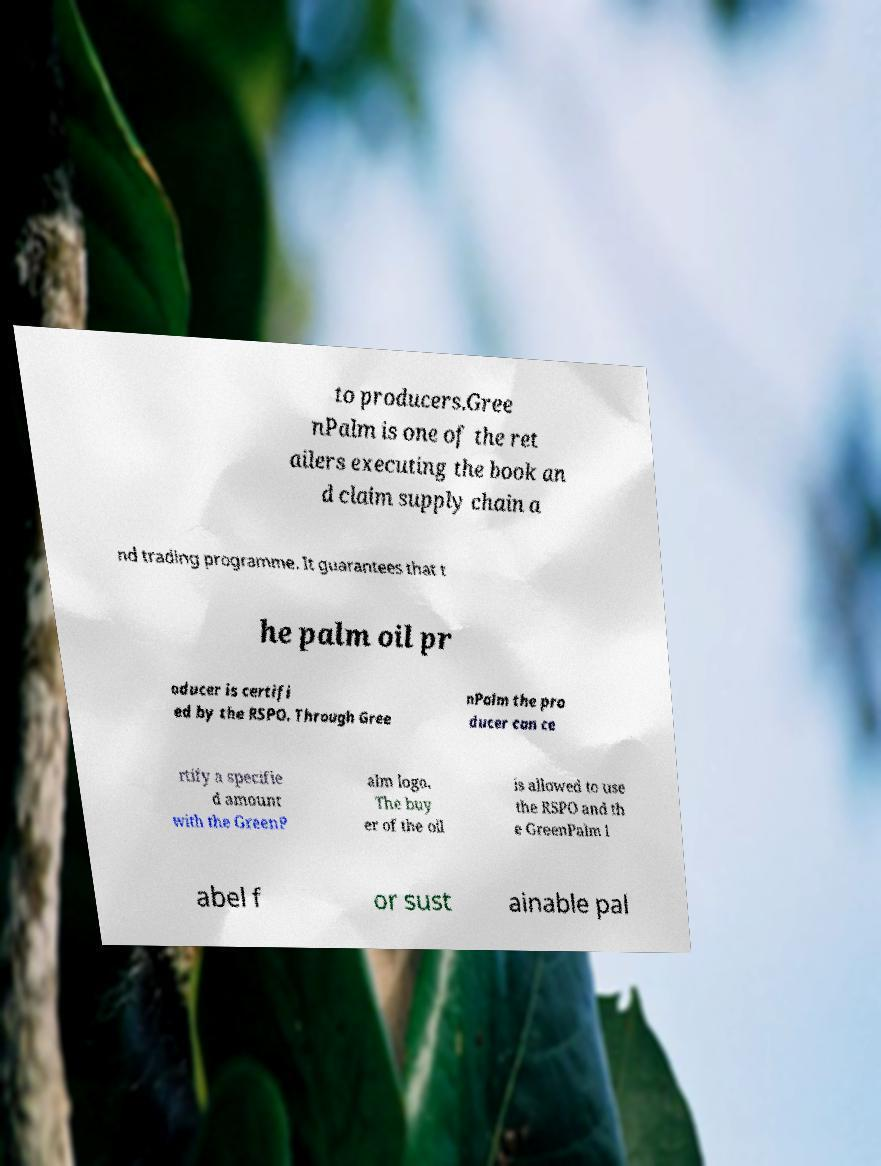I need the written content from this picture converted into text. Can you do that? to producers.Gree nPalm is one of the ret ailers executing the book an d claim supply chain a nd trading programme. It guarantees that t he palm oil pr oducer is certifi ed by the RSPO. Through Gree nPalm the pro ducer can ce rtify a specifie d amount with the GreenP alm logo. The buy er of the oil is allowed to use the RSPO and th e GreenPalm l abel f or sust ainable pal 